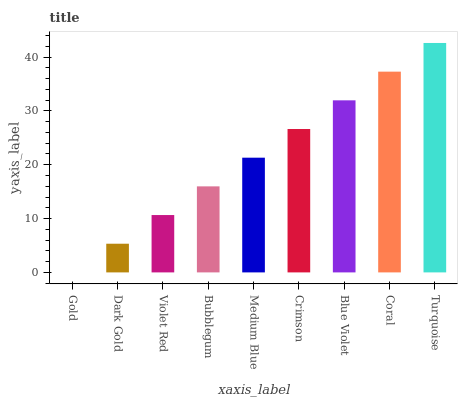Is Dark Gold the minimum?
Answer yes or no. No. Is Dark Gold the maximum?
Answer yes or no. No. Is Dark Gold greater than Gold?
Answer yes or no. Yes. Is Gold less than Dark Gold?
Answer yes or no. Yes. Is Gold greater than Dark Gold?
Answer yes or no. No. Is Dark Gold less than Gold?
Answer yes or no. No. Is Medium Blue the high median?
Answer yes or no. Yes. Is Medium Blue the low median?
Answer yes or no. Yes. Is Blue Violet the high median?
Answer yes or no. No. Is Crimson the low median?
Answer yes or no. No. 